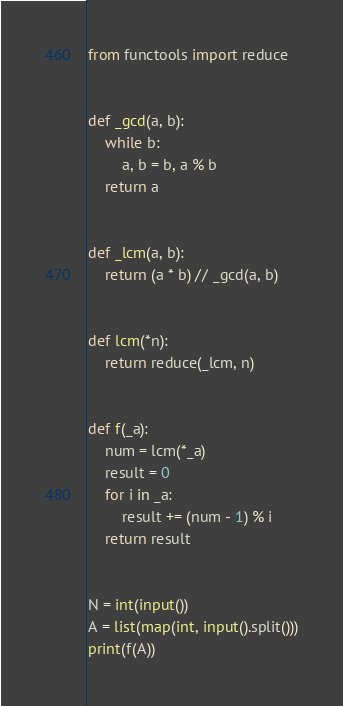Convert code to text. <code><loc_0><loc_0><loc_500><loc_500><_Python_>from functools import reduce


def _gcd(a, b):
    while b:
        a, b = b, a % b
    return a


def _lcm(a, b):
    return (a * b) // _gcd(a, b)


def lcm(*n):
    return reduce(_lcm, n)


def f(_a):
    num = lcm(*_a)
    result = 0
    for i in _a:
        result += (num - 1) % i
    return result


N = int(input())
A = list(map(int, input().split()))
print(f(A))
</code> 